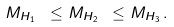Convert formula to latex. <formula><loc_0><loc_0><loc_500><loc_500>M _ { H _ { 1 } } \ \leq M _ { H _ { 2 } } \ \leq M _ { H _ { 3 } } \, .</formula> 